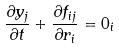Convert formula to latex. <formula><loc_0><loc_0><loc_500><loc_500>\frac { \partial y _ { j } } { \partial t } + \frac { \partial f _ { i j } } { \partial r _ { i } } = 0 _ { i }</formula> 